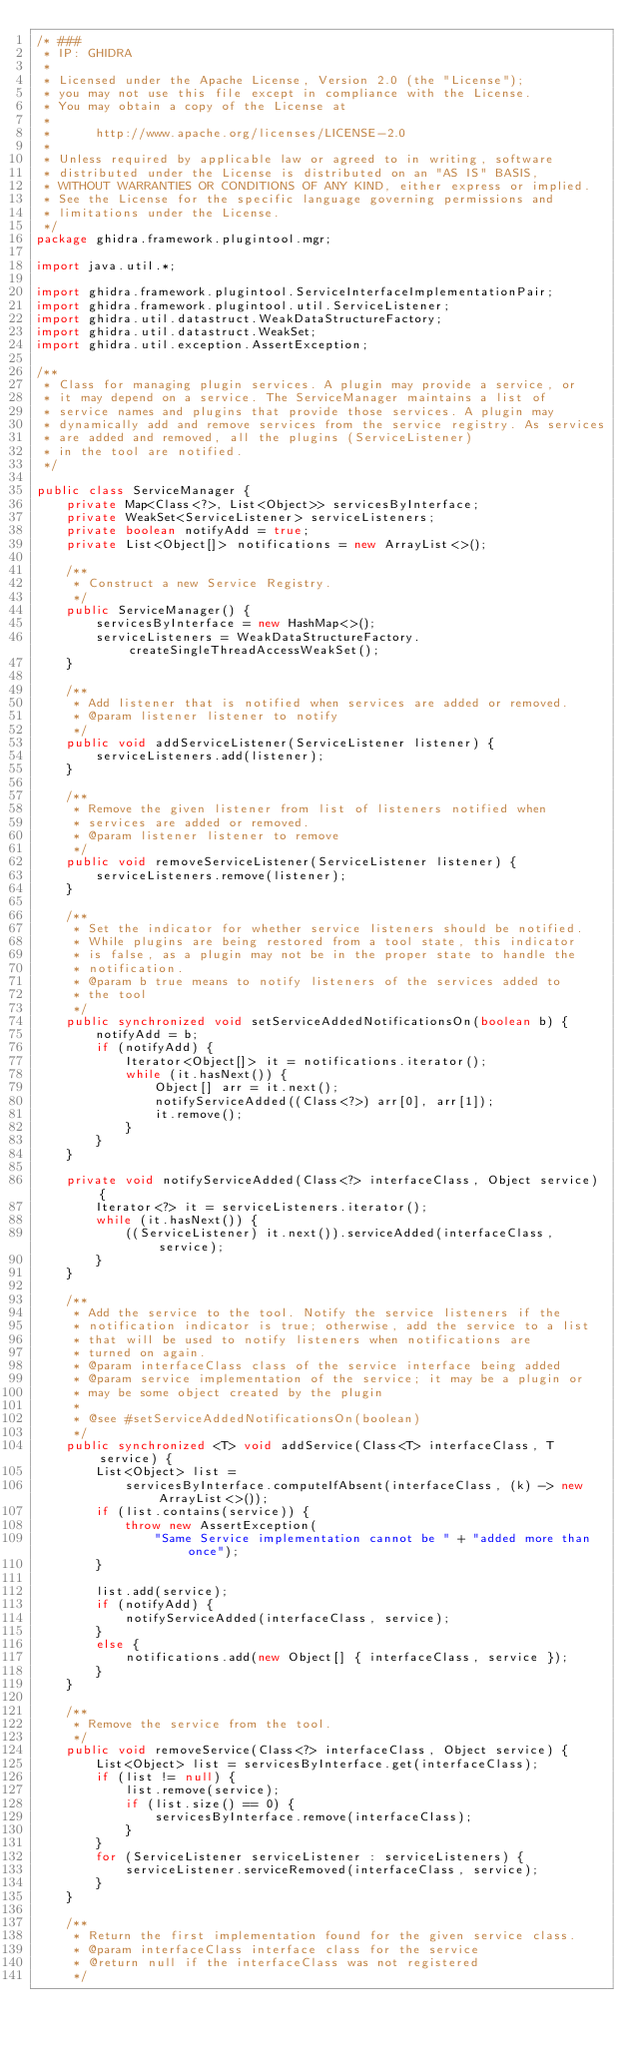<code> <loc_0><loc_0><loc_500><loc_500><_Java_>/* ###
 * IP: GHIDRA
 *
 * Licensed under the Apache License, Version 2.0 (the "License");
 * you may not use this file except in compliance with the License.
 * You may obtain a copy of the License at
 * 
 *      http://www.apache.org/licenses/LICENSE-2.0
 * 
 * Unless required by applicable law or agreed to in writing, software
 * distributed under the License is distributed on an "AS IS" BASIS,
 * WITHOUT WARRANTIES OR CONDITIONS OF ANY KIND, either express or implied.
 * See the License for the specific language governing permissions and
 * limitations under the License.
 */
package ghidra.framework.plugintool.mgr;

import java.util.*;

import ghidra.framework.plugintool.ServiceInterfaceImplementationPair;
import ghidra.framework.plugintool.util.ServiceListener;
import ghidra.util.datastruct.WeakDataStructureFactory;
import ghidra.util.datastruct.WeakSet;
import ghidra.util.exception.AssertException;

/**
 * Class for managing plugin services. A plugin may provide a service, or
 * it may depend on a service. The ServiceManager maintains a list of
 * service names and plugins that provide those services. A plugin may
 * dynamically add and remove services from the service registry. As services
 * are added and removed, all the plugins (ServiceListener) 
 * in the tool are notified.
 */

public class ServiceManager {
	private Map<Class<?>, List<Object>> servicesByInterface;
	private WeakSet<ServiceListener> serviceListeners;
	private boolean notifyAdd = true;
	private List<Object[]> notifications = new ArrayList<>();

	/**
	 * Construct a new Service Registry.
	 */
	public ServiceManager() {
		servicesByInterface = new HashMap<>();
		serviceListeners = WeakDataStructureFactory.createSingleThreadAccessWeakSet();
	}

	/**
	 * Add listener that is notified when services are added or removed.
	 * @param listener listener to notify
	 */
	public void addServiceListener(ServiceListener listener) {
		serviceListeners.add(listener);
	}

	/**
	 * Remove the given listener from list of listeners notified when
	 * services are added or removed.
	 * @param listener listener to remove
	 */
	public void removeServiceListener(ServiceListener listener) {
		serviceListeners.remove(listener);
	}

	/**
	 * Set the indicator for whether service listeners should be notified.
	 * While plugins are being restored from a tool state, this indicator
	 * is false, as a plugin may not be in the proper state to handle the
	 * notification.
	 * @param b true means to notify listeners of the services added to
	 * the tool
	 */
	public synchronized void setServiceAddedNotificationsOn(boolean b) {
		notifyAdd = b;
		if (notifyAdd) {
			Iterator<Object[]> it = notifications.iterator();
			while (it.hasNext()) {
				Object[] arr = it.next();
				notifyServiceAdded((Class<?>) arr[0], arr[1]);
				it.remove();
			}
		}
	}

	private void notifyServiceAdded(Class<?> interfaceClass, Object service) {
		Iterator<?> it = serviceListeners.iterator();
		while (it.hasNext()) {
			((ServiceListener) it.next()).serviceAdded(interfaceClass, service);
		}
	}

	/**
	 * Add the service to the tool. Notify the service listeners if the
	 * notification indicator is true; otherwise, add the service to a list
	 * that will be used to notify listeners when notifications are 
	 * turned on again.
	 * @param interfaceClass class of the service interface being added
	 * @param service implementation of the service; it may be a plugin or
	 * may be some object created by the plugin
	 * 
	 * @see #setServiceAddedNotificationsOn(boolean) 
	 */
	public synchronized <T> void addService(Class<T> interfaceClass, T service) {
		List<Object> list =
			servicesByInterface.computeIfAbsent(interfaceClass, (k) -> new ArrayList<>());
		if (list.contains(service)) {
			throw new AssertException(
				"Same Service implementation cannot be " + "added more than once");
		}

		list.add(service);
		if (notifyAdd) {
			notifyServiceAdded(interfaceClass, service);
		}
		else {
			notifications.add(new Object[] { interfaceClass, service });
		}
	}

	/**
	 * Remove the service from the tool.
	 */
	public void removeService(Class<?> interfaceClass, Object service) {
		List<Object> list = servicesByInterface.get(interfaceClass);
		if (list != null) {
			list.remove(service);
			if (list.size() == 0) {
				servicesByInterface.remove(interfaceClass);
			}
		}
		for (ServiceListener serviceListener : serviceListeners) {
			serviceListener.serviceRemoved(interfaceClass, service);
		}
	}

	/**
	 * Return the first implementation found for the given service class.
	 * @param interfaceClass interface class for the service
	 * @return null if the interfaceClass was not registered
	 */</code> 